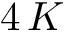<formula> <loc_0><loc_0><loc_500><loc_500>4 \, K</formula> 